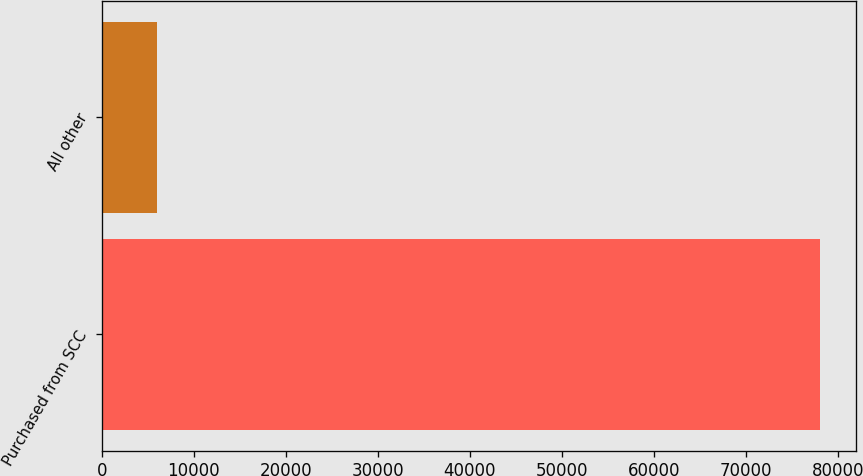<chart> <loc_0><loc_0><loc_500><loc_500><bar_chart><fcel>Purchased from SCC<fcel>All other<nl><fcel>78067<fcel>6006<nl></chart> 